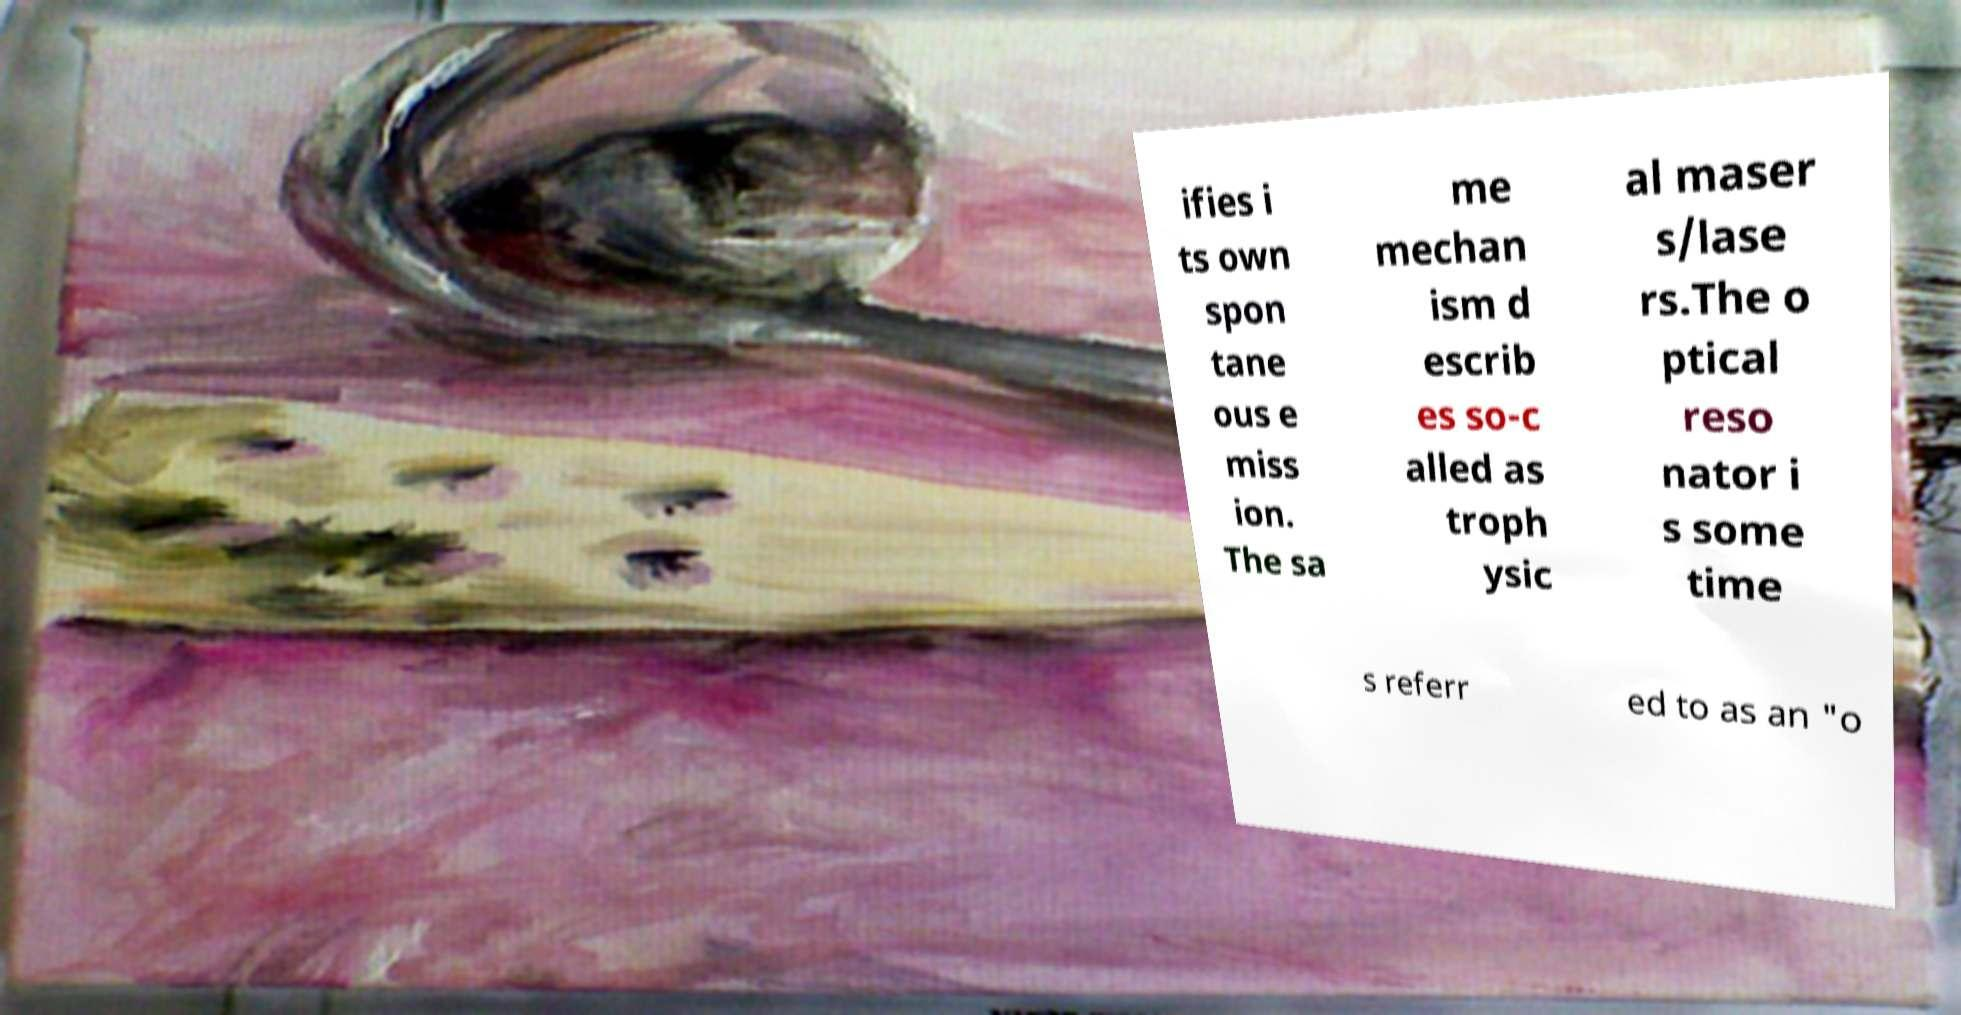Could you extract and type out the text from this image? ifies i ts own spon tane ous e miss ion. The sa me mechan ism d escrib es so-c alled as troph ysic al maser s/lase rs.The o ptical reso nator i s some time s referr ed to as an "o 